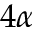<formula> <loc_0><loc_0><loc_500><loc_500>4 \alpha</formula> 